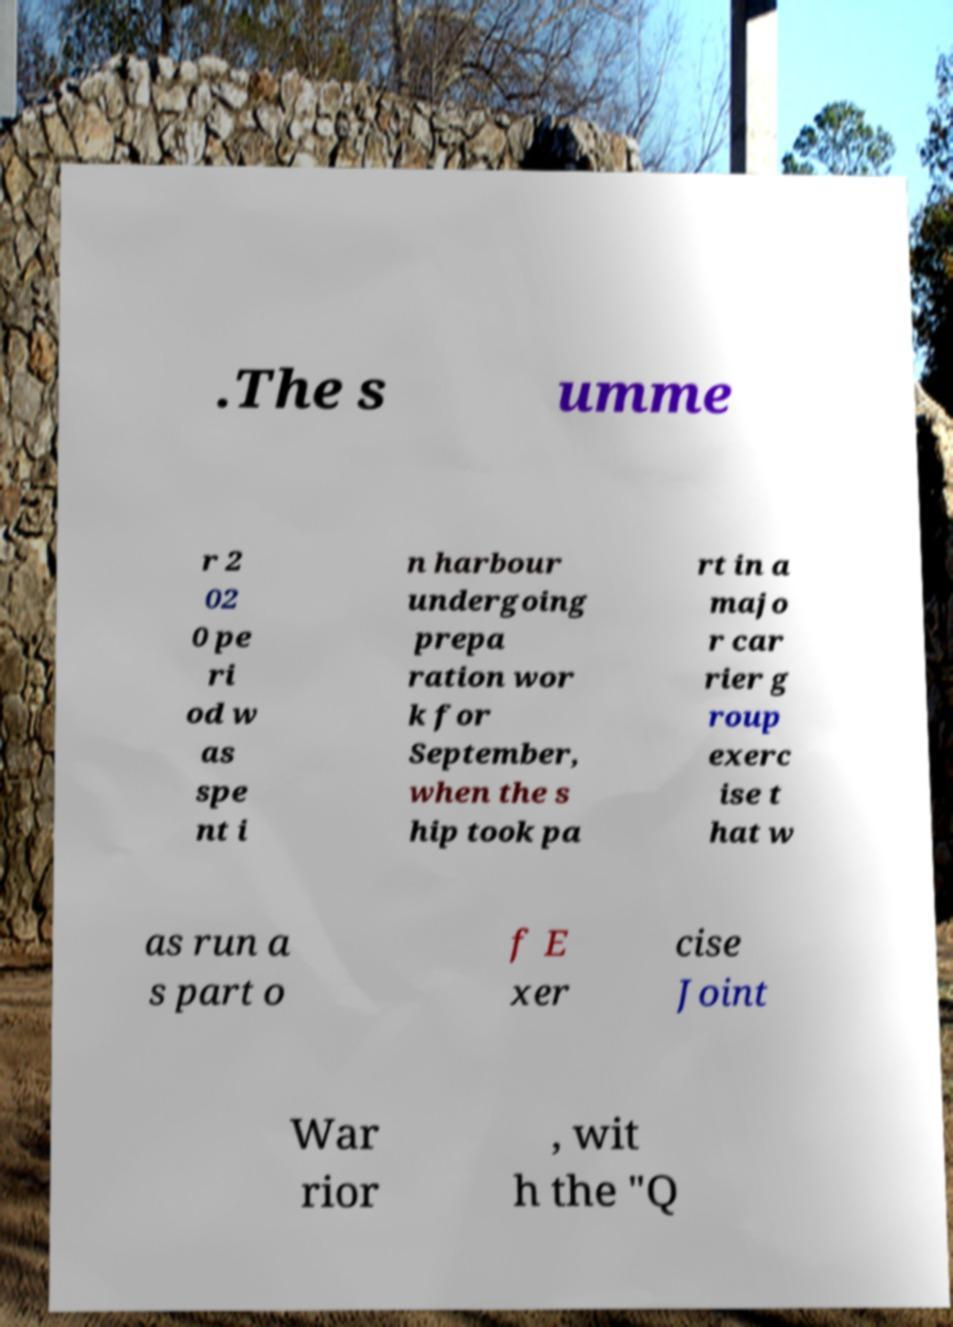What messages or text are displayed in this image? I need them in a readable, typed format. .The s umme r 2 02 0 pe ri od w as spe nt i n harbour undergoing prepa ration wor k for September, when the s hip took pa rt in a majo r car rier g roup exerc ise t hat w as run a s part o f E xer cise Joint War rior , wit h the "Q 